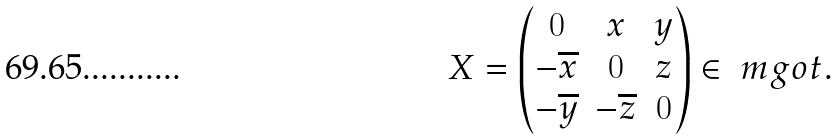<formula> <loc_0><loc_0><loc_500><loc_500>X = \begin{pmatrix} 0 & x & y \\ - \overline { x } & 0 & z \\ - \overline { y } & - \overline { z } & 0 \\ \end{pmatrix} \in \ m g o t .</formula> 